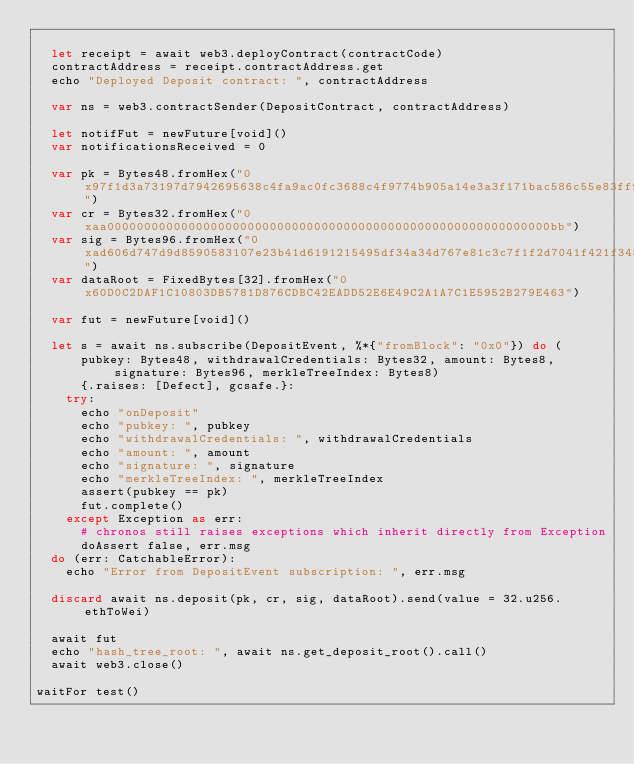<code> <loc_0><loc_0><loc_500><loc_500><_Nim_>
  let receipt = await web3.deployContract(contractCode)
  contractAddress = receipt.contractAddress.get
  echo "Deployed Deposit contract: ", contractAddress

  var ns = web3.contractSender(DepositContract, contractAddress)

  let notifFut = newFuture[void]()
  var notificationsReceived = 0

  var pk = Bytes48.fromHex("0x97f1d3a73197d7942695638c4fa9ac0fc3688c4f9774b905a14e3a3f171bac586c55e83ff97a1aeffb3af00adb22c6bb")
  var cr = Bytes32.fromHex("0xaa000000000000000000000000000000000000000000000000000000000000bb")
  var sig = Bytes96.fromHex("0xad606d747d9d8590583107e23b41d6191215495df34a34d767e81c3c7f1f2d7041f421f3486186044a02c3dd65a05b44061455c2ca7d6525db68d5fa146e34de8234d3acd8de7e00b971acd4458b740fa6368d437db2c8dae6b2011db9be2f07")
  var dataRoot = FixedBytes[32].fromHex("0x60D0C2DAF1C10803DB5781D876CDBC42EADD52E6E49C2A1A7C1E5952B279E463")

  var fut = newFuture[void]()

  let s = await ns.subscribe(DepositEvent, %*{"fromBlock": "0x0"}) do (
      pubkey: Bytes48, withdrawalCredentials: Bytes32, amount: Bytes8, signature: Bytes96, merkleTreeIndex: Bytes8)
      {.raises: [Defect], gcsafe.}:
    try:
      echo "onDeposit"
      echo "pubkey: ", pubkey
      echo "withdrawalCredentials: ", withdrawalCredentials
      echo "amount: ", amount
      echo "signature: ", signature
      echo "merkleTreeIndex: ", merkleTreeIndex
      assert(pubkey == pk)
      fut.complete()
    except Exception as err:
      # chronos still raises exceptions which inherit directly from Exception
      doAssert false, err.msg
  do (err: CatchableError):
    echo "Error from DepositEvent subscription: ", err.msg

  discard await ns.deposit(pk, cr, sig, dataRoot).send(value = 32.u256.ethToWei)

  await fut
  echo "hash_tree_root: ", await ns.get_deposit_root().call()
  await web3.close()

waitFor test()
</code> 